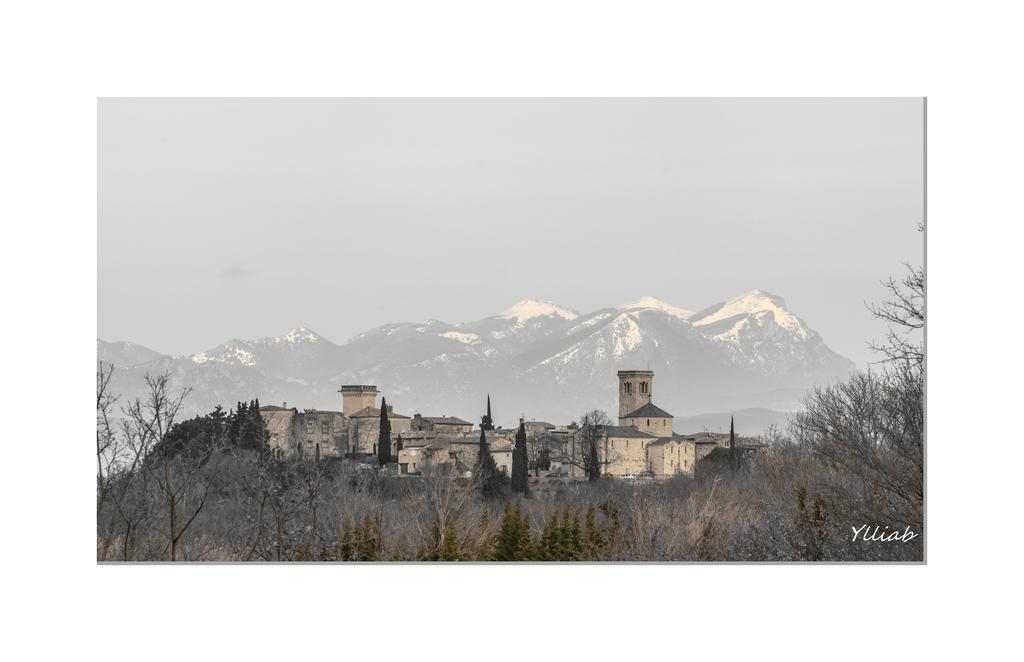What is the main structure in the center of the image? There is a castle in the center of the image. What type of vegetation is present at the bottom of the image? There are trees at the bottom of the image. What can be seen in the background of the image? There are hills and the sky visible in the background of the image. What type of berry is hanging from the curtain in the image? There is no curtain or berry present in the image. How many bells can be heard ringing in the image? There are no bells present in the image, so it is not possible to determine how many might be ringing. 